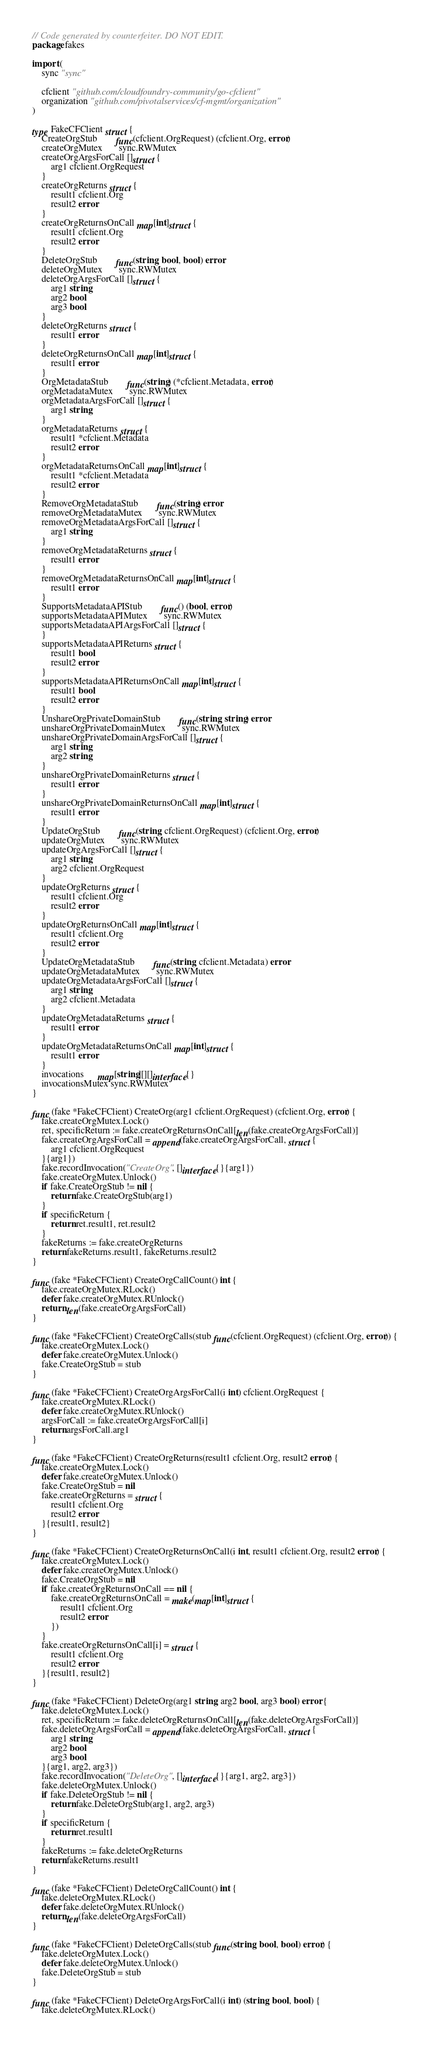Convert code to text. <code><loc_0><loc_0><loc_500><loc_500><_Go_>// Code generated by counterfeiter. DO NOT EDIT.
package fakes

import (
	sync "sync"

	cfclient "github.com/cloudfoundry-community/go-cfclient"
	organization "github.com/pivotalservices/cf-mgmt/organization"
)

type FakeCFClient struct {
	CreateOrgStub        func(cfclient.OrgRequest) (cfclient.Org, error)
	createOrgMutex       sync.RWMutex
	createOrgArgsForCall []struct {
		arg1 cfclient.OrgRequest
	}
	createOrgReturns struct {
		result1 cfclient.Org
		result2 error
	}
	createOrgReturnsOnCall map[int]struct {
		result1 cfclient.Org
		result2 error
	}
	DeleteOrgStub        func(string, bool, bool) error
	deleteOrgMutex       sync.RWMutex
	deleteOrgArgsForCall []struct {
		arg1 string
		arg2 bool
		arg3 bool
	}
	deleteOrgReturns struct {
		result1 error
	}
	deleteOrgReturnsOnCall map[int]struct {
		result1 error
	}
	OrgMetadataStub        func(string) (*cfclient.Metadata, error)
	orgMetadataMutex       sync.RWMutex
	orgMetadataArgsForCall []struct {
		arg1 string
	}
	orgMetadataReturns struct {
		result1 *cfclient.Metadata
		result2 error
	}
	orgMetadataReturnsOnCall map[int]struct {
		result1 *cfclient.Metadata
		result2 error
	}
	RemoveOrgMetadataStub        func(string) error
	removeOrgMetadataMutex       sync.RWMutex
	removeOrgMetadataArgsForCall []struct {
		arg1 string
	}
	removeOrgMetadataReturns struct {
		result1 error
	}
	removeOrgMetadataReturnsOnCall map[int]struct {
		result1 error
	}
	SupportsMetadataAPIStub        func() (bool, error)
	supportsMetadataAPIMutex       sync.RWMutex
	supportsMetadataAPIArgsForCall []struct {
	}
	supportsMetadataAPIReturns struct {
		result1 bool
		result2 error
	}
	supportsMetadataAPIReturnsOnCall map[int]struct {
		result1 bool
		result2 error
	}
	UnshareOrgPrivateDomainStub        func(string, string) error
	unshareOrgPrivateDomainMutex       sync.RWMutex
	unshareOrgPrivateDomainArgsForCall []struct {
		arg1 string
		arg2 string
	}
	unshareOrgPrivateDomainReturns struct {
		result1 error
	}
	unshareOrgPrivateDomainReturnsOnCall map[int]struct {
		result1 error
	}
	UpdateOrgStub        func(string, cfclient.OrgRequest) (cfclient.Org, error)
	updateOrgMutex       sync.RWMutex
	updateOrgArgsForCall []struct {
		arg1 string
		arg2 cfclient.OrgRequest
	}
	updateOrgReturns struct {
		result1 cfclient.Org
		result2 error
	}
	updateOrgReturnsOnCall map[int]struct {
		result1 cfclient.Org
		result2 error
	}
	UpdateOrgMetadataStub        func(string, cfclient.Metadata) error
	updateOrgMetadataMutex       sync.RWMutex
	updateOrgMetadataArgsForCall []struct {
		arg1 string
		arg2 cfclient.Metadata
	}
	updateOrgMetadataReturns struct {
		result1 error
	}
	updateOrgMetadataReturnsOnCall map[int]struct {
		result1 error
	}
	invocations      map[string][][]interface{}
	invocationsMutex sync.RWMutex
}

func (fake *FakeCFClient) CreateOrg(arg1 cfclient.OrgRequest) (cfclient.Org, error) {
	fake.createOrgMutex.Lock()
	ret, specificReturn := fake.createOrgReturnsOnCall[len(fake.createOrgArgsForCall)]
	fake.createOrgArgsForCall = append(fake.createOrgArgsForCall, struct {
		arg1 cfclient.OrgRequest
	}{arg1})
	fake.recordInvocation("CreateOrg", []interface{}{arg1})
	fake.createOrgMutex.Unlock()
	if fake.CreateOrgStub != nil {
		return fake.CreateOrgStub(arg1)
	}
	if specificReturn {
		return ret.result1, ret.result2
	}
	fakeReturns := fake.createOrgReturns
	return fakeReturns.result1, fakeReturns.result2
}

func (fake *FakeCFClient) CreateOrgCallCount() int {
	fake.createOrgMutex.RLock()
	defer fake.createOrgMutex.RUnlock()
	return len(fake.createOrgArgsForCall)
}

func (fake *FakeCFClient) CreateOrgCalls(stub func(cfclient.OrgRequest) (cfclient.Org, error)) {
	fake.createOrgMutex.Lock()
	defer fake.createOrgMutex.Unlock()
	fake.CreateOrgStub = stub
}

func (fake *FakeCFClient) CreateOrgArgsForCall(i int) cfclient.OrgRequest {
	fake.createOrgMutex.RLock()
	defer fake.createOrgMutex.RUnlock()
	argsForCall := fake.createOrgArgsForCall[i]
	return argsForCall.arg1
}

func (fake *FakeCFClient) CreateOrgReturns(result1 cfclient.Org, result2 error) {
	fake.createOrgMutex.Lock()
	defer fake.createOrgMutex.Unlock()
	fake.CreateOrgStub = nil
	fake.createOrgReturns = struct {
		result1 cfclient.Org
		result2 error
	}{result1, result2}
}

func (fake *FakeCFClient) CreateOrgReturnsOnCall(i int, result1 cfclient.Org, result2 error) {
	fake.createOrgMutex.Lock()
	defer fake.createOrgMutex.Unlock()
	fake.CreateOrgStub = nil
	if fake.createOrgReturnsOnCall == nil {
		fake.createOrgReturnsOnCall = make(map[int]struct {
			result1 cfclient.Org
			result2 error
		})
	}
	fake.createOrgReturnsOnCall[i] = struct {
		result1 cfclient.Org
		result2 error
	}{result1, result2}
}

func (fake *FakeCFClient) DeleteOrg(arg1 string, arg2 bool, arg3 bool) error {
	fake.deleteOrgMutex.Lock()
	ret, specificReturn := fake.deleteOrgReturnsOnCall[len(fake.deleteOrgArgsForCall)]
	fake.deleteOrgArgsForCall = append(fake.deleteOrgArgsForCall, struct {
		arg1 string
		arg2 bool
		arg3 bool
	}{arg1, arg2, arg3})
	fake.recordInvocation("DeleteOrg", []interface{}{arg1, arg2, arg3})
	fake.deleteOrgMutex.Unlock()
	if fake.DeleteOrgStub != nil {
		return fake.DeleteOrgStub(arg1, arg2, arg3)
	}
	if specificReturn {
		return ret.result1
	}
	fakeReturns := fake.deleteOrgReturns
	return fakeReturns.result1
}

func (fake *FakeCFClient) DeleteOrgCallCount() int {
	fake.deleteOrgMutex.RLock()
	defer fake.deleteOrgMutex.RUnlock()
	return len(fake.deleteOrgArgsForCall)
}

func (fake *FakeCFClient) DeleteOrgCalls(stub func(string, bool, bool) error) {
	fake.deleteOrgMutex.Lock()
	defer fake.deleteOrgMutex.Unlock()
	fake.DeleteOrgStub = stub
}

func (fake *FakeCFClient) DeleteOrgArgsForCall(i int) (string, bool, bool) {
	fake.deleteOrgMutex.RLock()</code> 